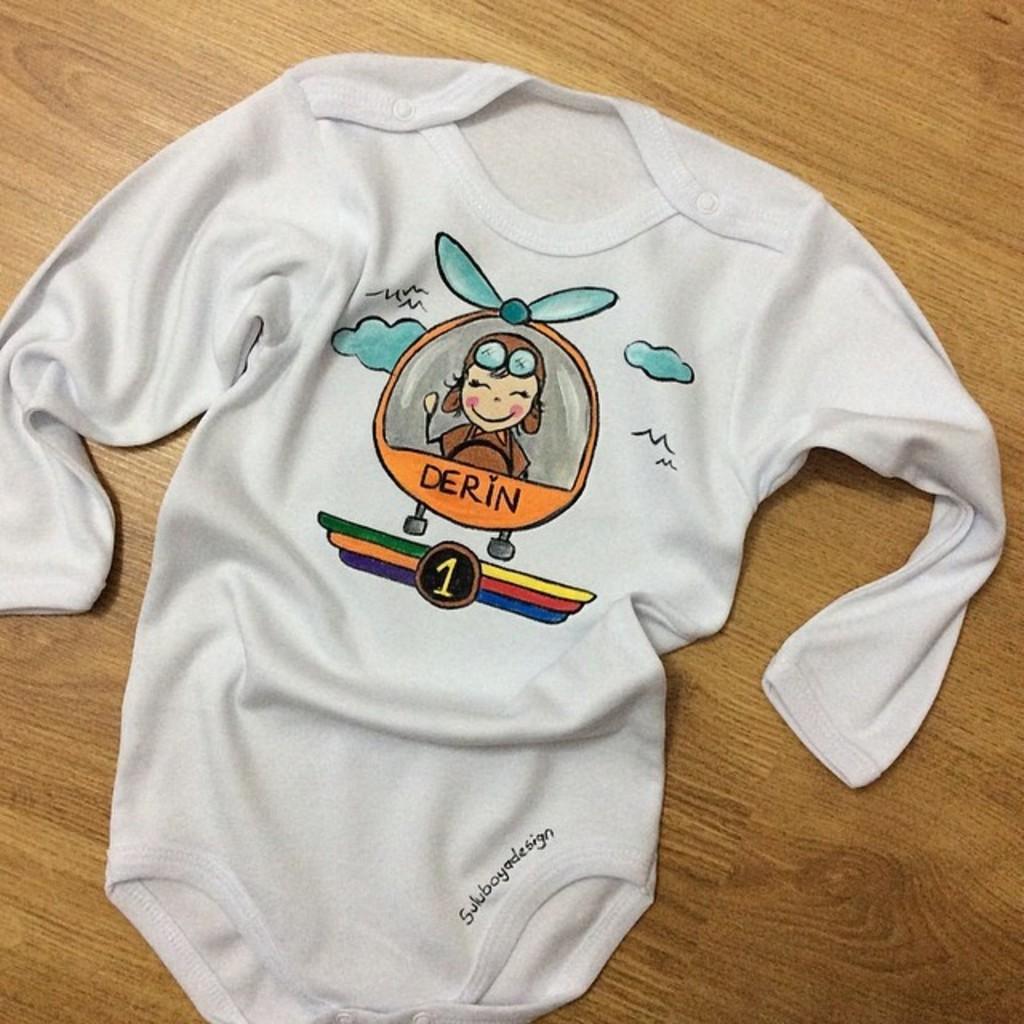In one or two sentences, can you explain what this image depicts? In the picture I can see a white color cloth which has cartoon image and something written on it. This cloth is on a wooden surface. 